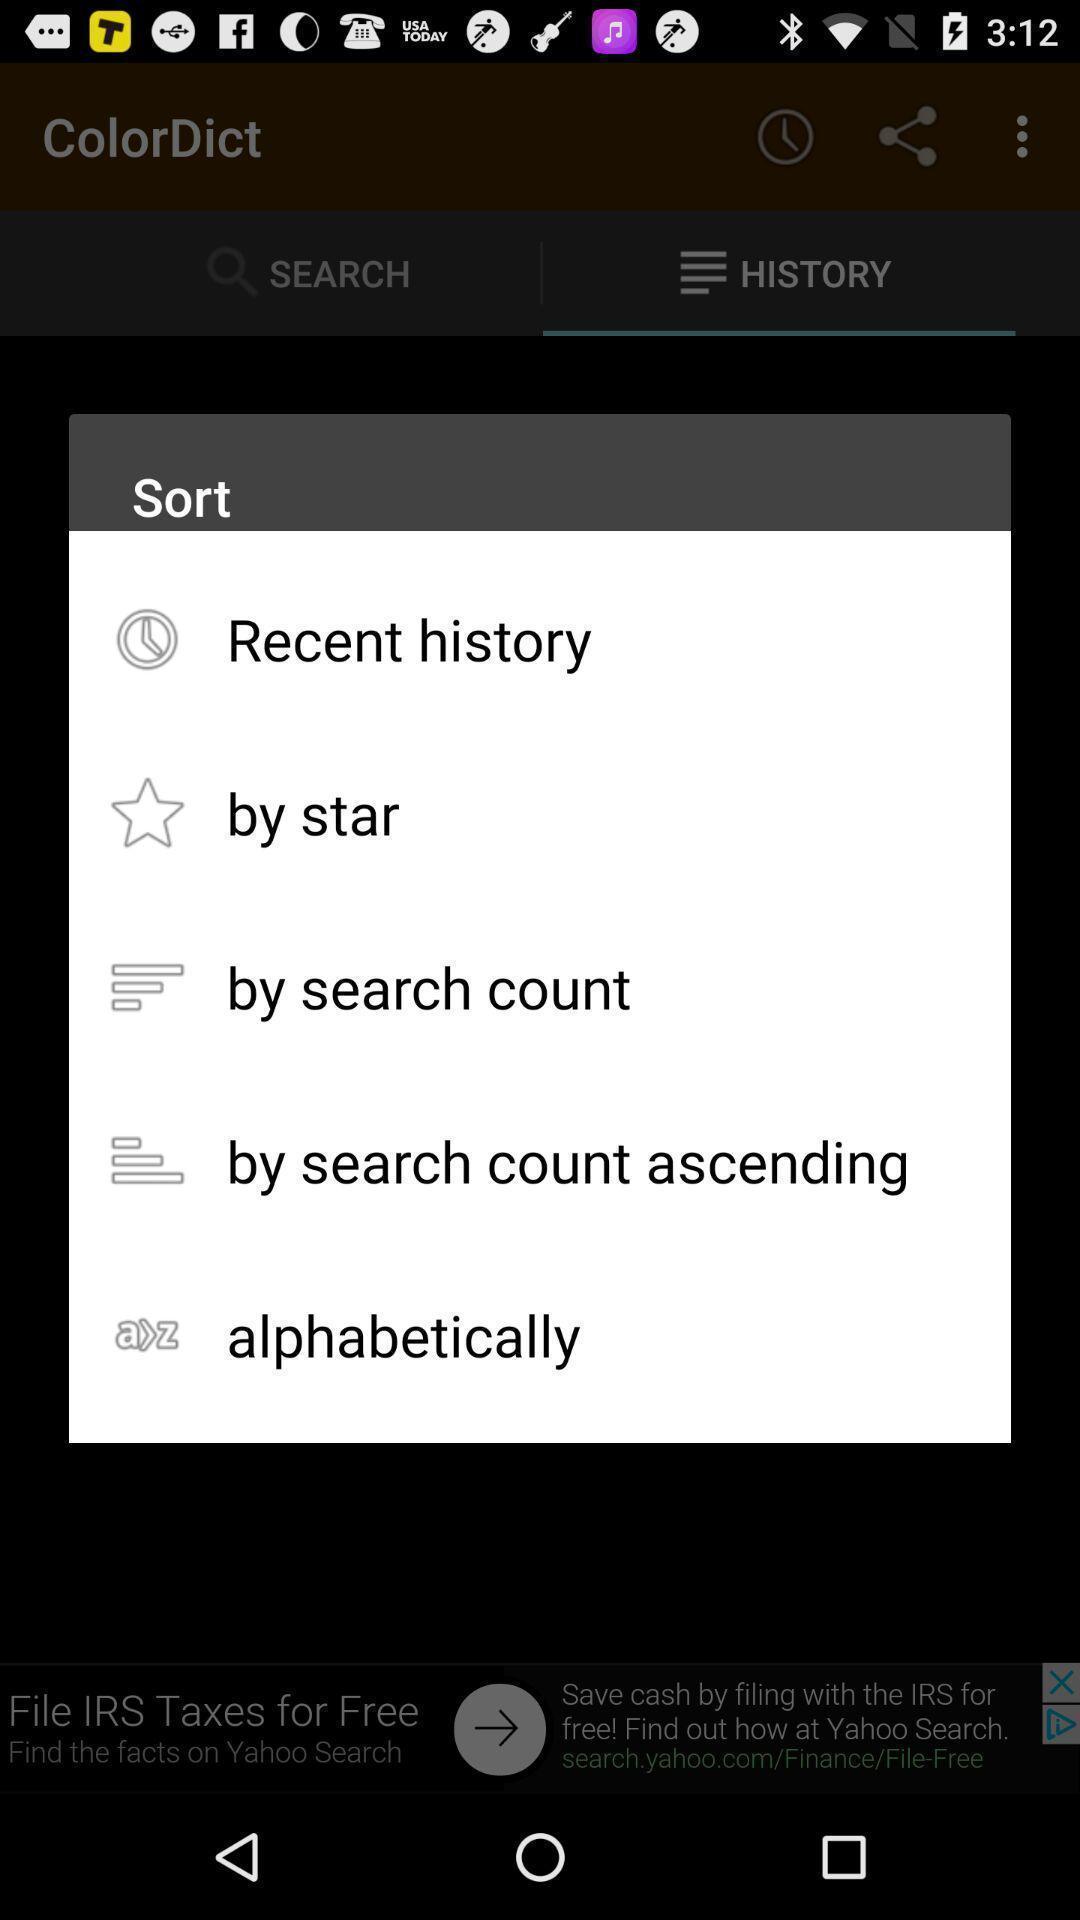Describe this image in words. Popup to sort the options in the dictionary app. 